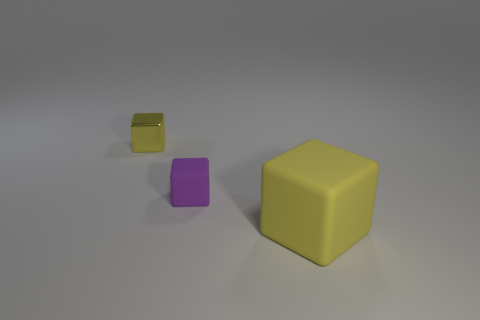How many large things are either spheres or purple matte things?
Give a very brief answer. 0. There is a purple object; how many large yellow rubber blocks are right of it?
Give a very brief answer. 1. Is the number of cubes that are in front of the big rubber cube greater than the number of matte blocks?
Your answer should be very brief. No. There is a small thing that is the same material as the large object; what shape is it?
Make the answer very short. Cube. What color is the thing that is in front of the matte block behind the big thing?
Your answer should be very brief. Yellow. Do the large yellow object and the tiny purple object have the same shape?
Offer a very short reply. Yes. What is the material of the tiny yellow object that is the same shape as the purple rubber object?
Ensure brevity in your answer.  Metal. There is a yellow block that is in front of the yellow thing that is on the left side of the yellow rubber thing; is there a tiny yellow metal cube that is in front of it?
Offer a very short reply. No. There is a yellow shiny thing; does it have the same shape as the matte object that is behind the large yellow matte object?
Provide a short and direct response. Yes. Is there anything else that has the same color as the small matte cube?
Make the answer very short. No. 